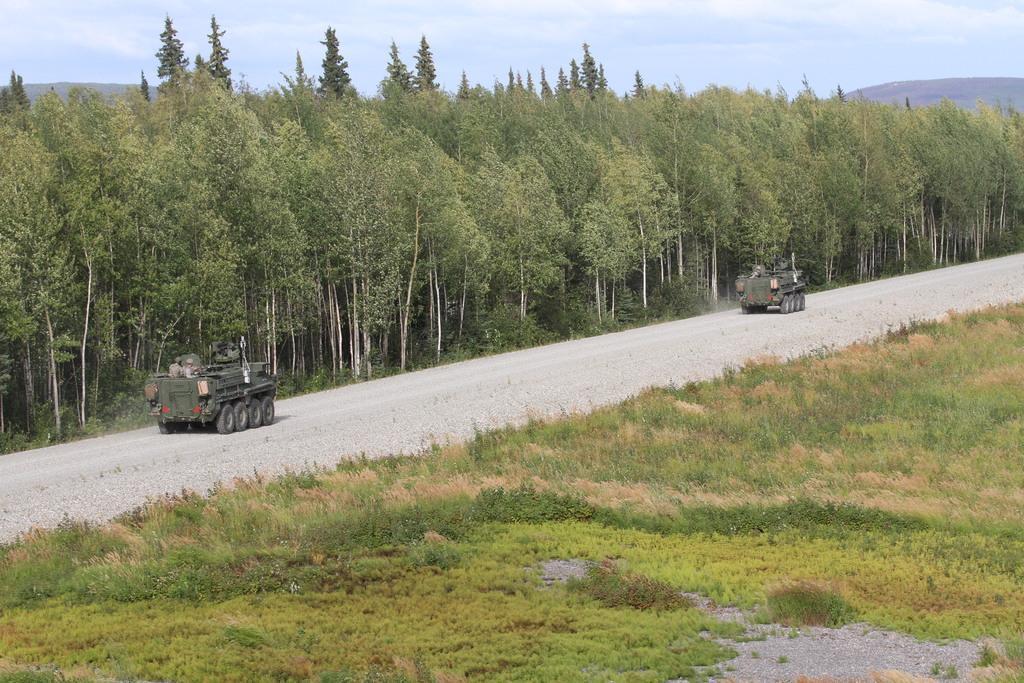What type of vegetation is present in the image? There is grass in the image. What else can be seen on the surface in the image? There are vehicles visible on the surface in the image. What other natural elements are present in the image? There are trees in the image. What can be seen in the distance in the image? There are hills visible in the background of the image. What is visible above the hills in the image? The sky is visible in the background of the image, and clouds are present in the sky. What language are the people discussing in the image? There are no people present in the image, so it is not possible to determine the language being discussed. 